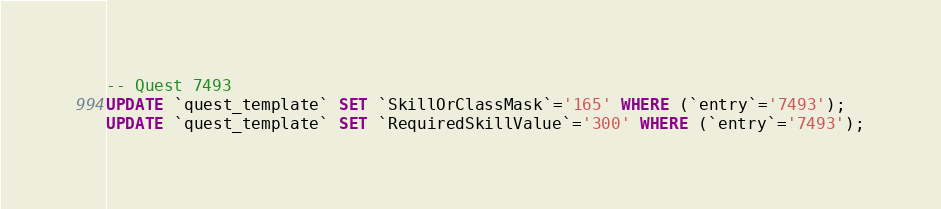Convert code to text. <code><loc_0><loc_0><loc_500><loc_500><_SQL_>-- Quest 7493
UPDATE `quest_template` SET `SkillOrClassMask`='165' WHERE (`entry`='7493');
UPDATE `quest_template` SET `RequiredSkillValue`='300' WHERE (`entry`='7493');
</code> 